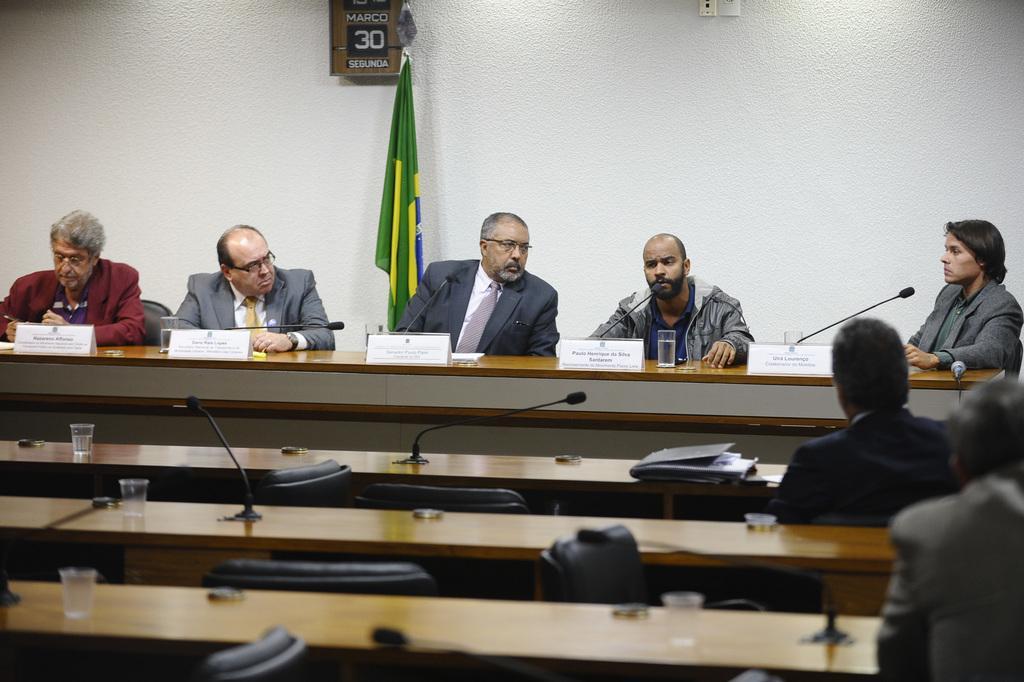How would you summarize this image in a sentence or two? The image is taken inside a room. The room is filled with tables. There are glasses, mic´s, papers placed on the tables. There are people sitting on the chairs. In the background there is a wall and a flag. 